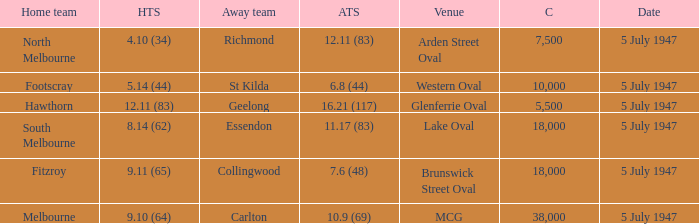What away team played against Footscray as the home team? St Kilda. 